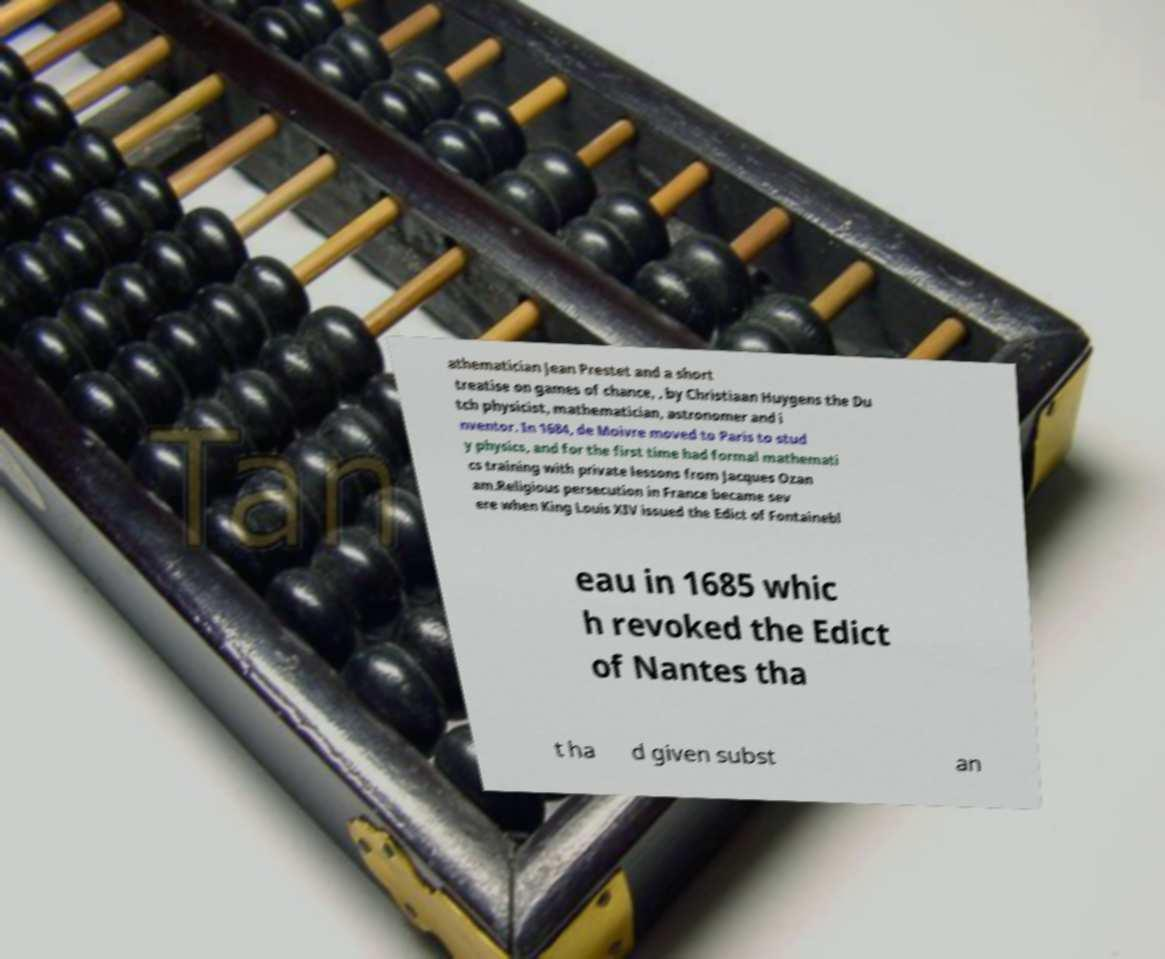Can you read and provide the text displayed in the image?This photo seems to have some interesting text. Can you extract and type it out for me? athematician Jean Prestet and a short treatise on games of chance, , by Christiaan Huygens the Du tch physicist, mathematician, astronomer and i nventor. In 1684, de Moivre moved to Paris to stud y physics, and for the first time had formal mathemati cs training with private lessons from Jacques Ozan am.Religious persecution in France became sev ere when King Louis XIV issued the Edict of Fontainebl eau in 1685 whic h revoked the Edict of Nantes tha t ha d given subst an 